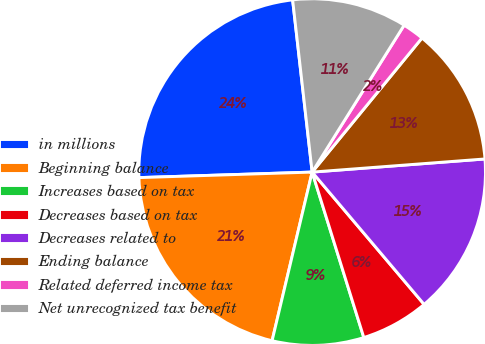<chart> <loc_0><loc_0><loc_500><loc_500><pie_chart><fcel>in millions<fcel>Beginning balance<fcel>Increases based on tax<fcel>Decreases based on tax<fcel>Decreases related to<fcel>Ending balance<fcel>Related deferred income tax<fcel>Net unrecognized tax benefit<nl><fcel>23.71%<fcel>20.78%<fcel>8.53%<fcel>6.36%<fcel>15.03%<fcel>12.87%<fcel>2.02%<fcel>10.7%<nl></chart> 